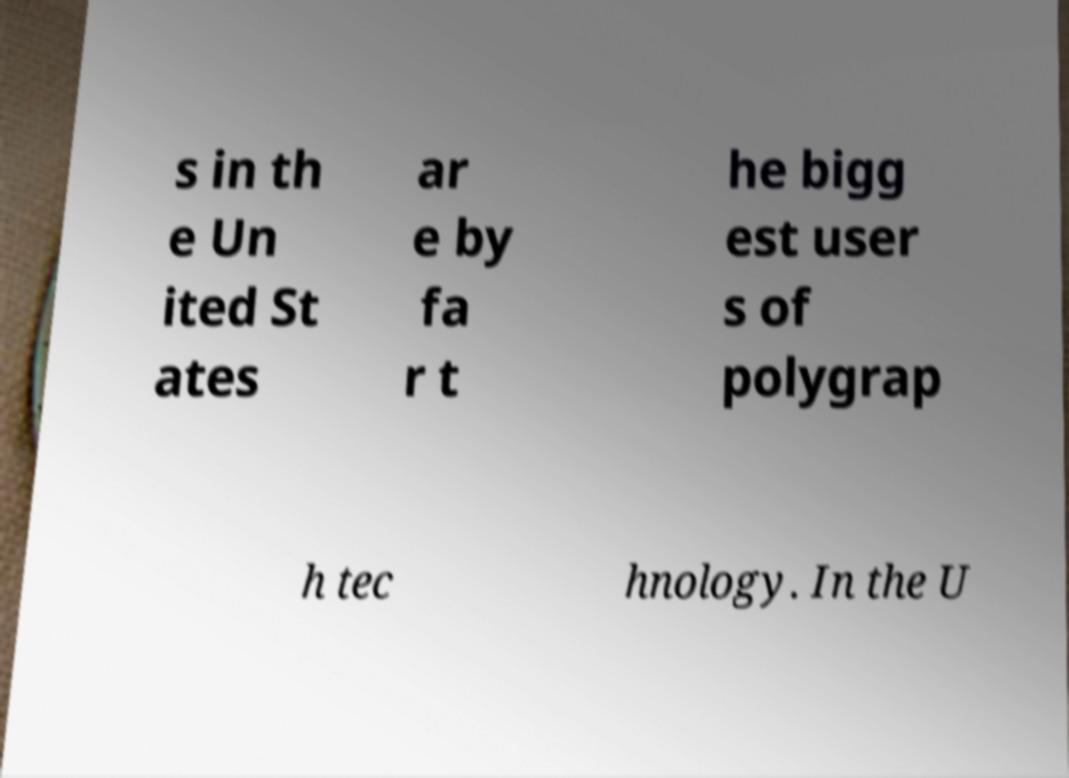Can you accurately transcribe the text from the provided image for me? s in th e Un ited St ates ar e by fa r t he bigg est user s of polygrap h tec hnology. In the U 